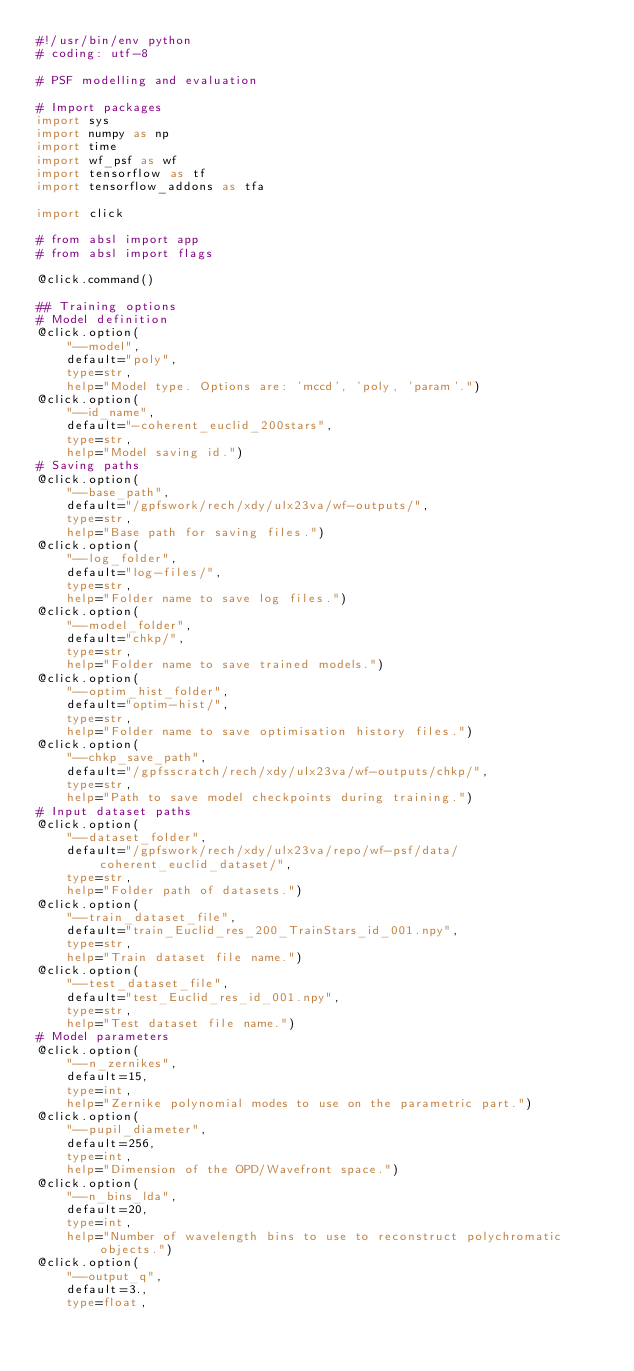<code> <loc_0><loc_0><loc_500><loc_500><_Python_>#!/usr/bin/env python
# coding: utf-8

# PSF modelling and evaluation

# Import packages
import sys
import numpy as np
import time
import wf_psf as wf
import tensorflow as tf
import tensorflow_addons as tfa

import click

# from absl import app
# from absl import flags

@click.command()

## Training options
# Model definition
@click.option(
    "--model",
    default="poly",
    type=str,
    help="Model type. Options are: 'mccd', 'poly, 'param'.")
@click.option(
    "--id_name",
    default="-coherent_euclid_200stars",
    type=str,
    help="Model saving id.")
# Saving paths
@click.option(
    "--base_path",
    default="/gpfswork/rech/xdy/ulx23va/wf-outputs/",
    type=str,
    help="Base path for saving files.")
@click.option(
    "--log_folder",
    default="log-files/",
    type=str,
    help="Folder name to save log files.")
@click.option(
    "--model_folder",
    default="chkp/",
    type=str,
    help="Folder name to save trained models.")
@click.option(
    "--optim_hist_folder",
    default="optim-hist/",
    type=str,
    help="Folder name to save optimisation history files.")
@click.option(
    "--chkp_save_path",
    default="/gpfsscratch/rech/xdy/ulx23va/wf-outputs/chkp/",
    type=str,
    help="Path to save model checkpoints during training.")
# Input dataset paths
@click.option(
    "--dataset_folder",
    default="/gpfswork/rech/xdy/ulx23va/repo/wf-psf/data/coherent_euclid_dataset/",
    type=str,
    help="Folder path of datasets.")
@click.option(
    "--train_dataset_file",
    default="train_Euclid_res_200_TrainStars_id_001.npy",
    type=str,
    help="Train dataset file name.")
@click.option(
    "--test_dataset_file",
    default="test_Euclid_res_id_001.npy",
    type=str,
    help="Test dataset file name.")
# Model parameters
@click.option(
    "--n_zernikes",
    default=15,
    type=int,
    help="Zernike polynomial modes to use on the parametric part.")
@click.option(
    "--pupil_diameter",
    default=256,
    type=int,
    help="Dimension of the OPD/Wavefront space.")
@click.option(
    "--n_bins_lda",
    default=20,
    type=int,
    help="Number of wavelength bins to use to reconstruct polychromatic objects.")
@click.option(
    "--output_q",
    default=3.,
    type=float,</code> 